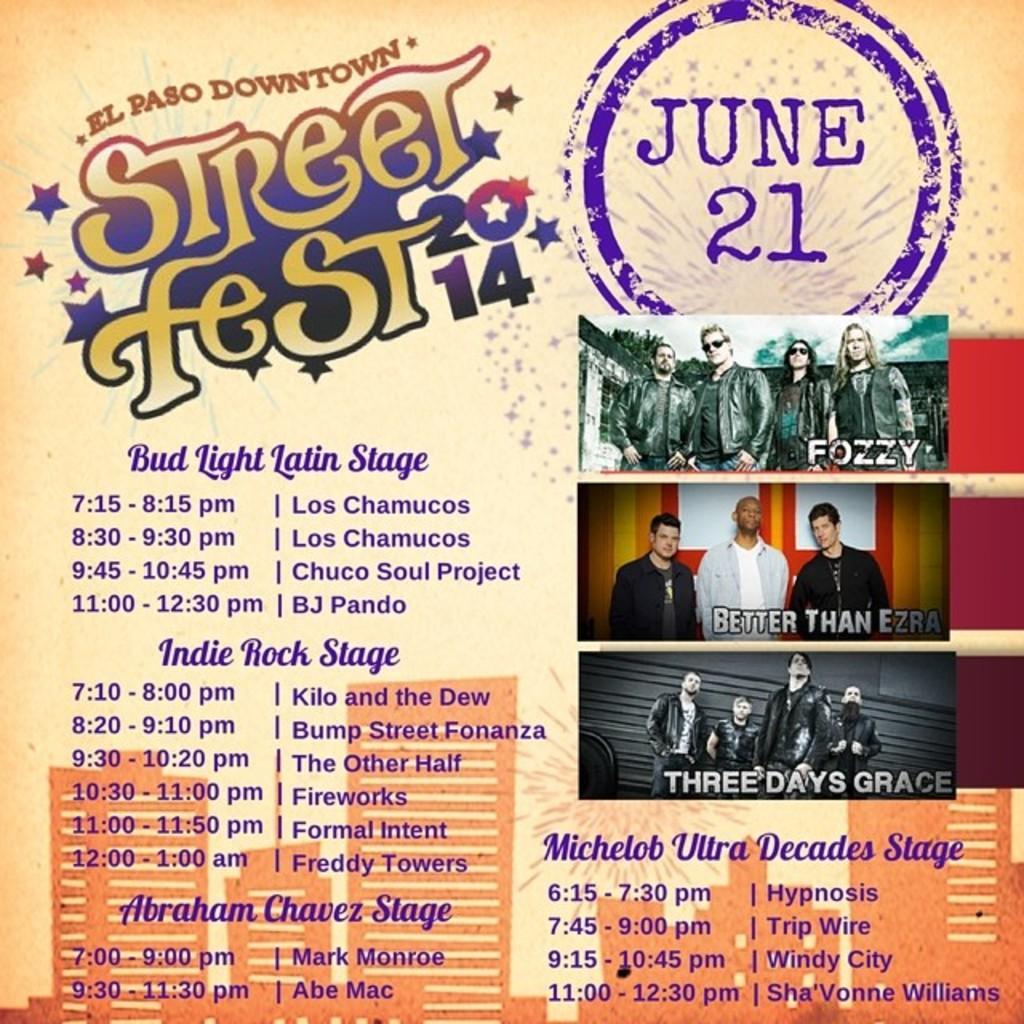Describe this image in one or two sentences. This is a poster. In this poster, we can see there are three images of the persons, there are paintings of the buildings and there are texts in different colors. And the background is cream in color. 